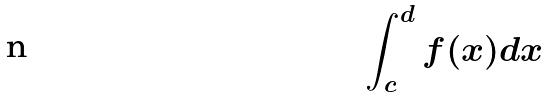Convert formula to latex. <formula><loc_0><loc_0><loc_500><loc_500>\int _ { c } ^ { d } f ( x ) d x</formula> 